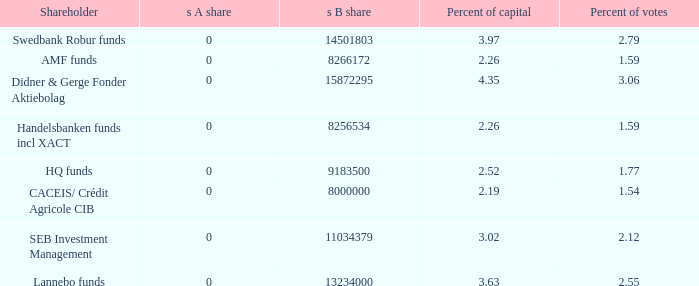What is the percent of capital for the shareholder that has a s B share of 8256534?  2.26. 